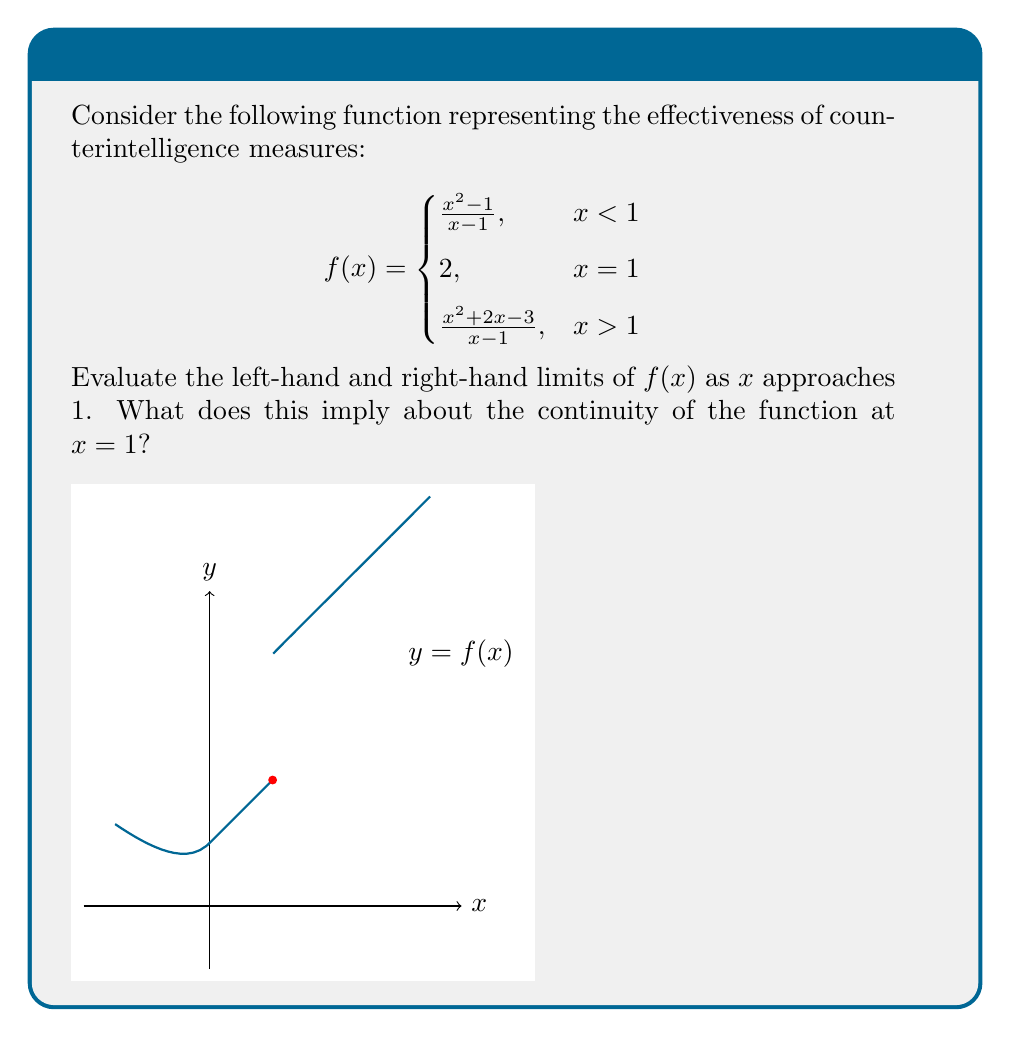Show me your answer to this math problem. Let's approach this step-by-step:

1) For the left-hand limit, we use the first piece of the function:
   $$\lim_{x \to 1^-} f(x) = \lim_{x \to 1^-} \frac{x^2 - 1}{x - 1}$$

   We can factor the numerator:
   $$\lim_{x \to 1^-} \frac{(x+1)(x-1)}{x - 1}$$

   The $(x-1)$ terms cancel out:
   $$\lim_{x \to 1^-} (x+1) = 2$$

2) For the right-hand limit, we use the third piece of the function:
   $$\lim_{x \to 1^+} f(x) = \lim_{x \to 1^+} \frac{x^2 + 2x - 3}{x - 1}$$

   We can factor the numerator:
   $$\lim_{x \to 1^+} \frac{(x+3)(x-1)}{x - 1}$$

   The $(x-1)$ terms cancel out:
   $$\lim_{x \to 1^+} (x+3) = 4$$

3) We see that the left-hand limit (2) and the right-hand limit (4) are different. This means the function is not continuous at $x = 1$.

4) Moreover, neither limit matches the function value at $x = 1$, which is 2.

From a counterintelligence perspective, this discontinuity could represent a sudden change in effectiveness when crossing a certain threshold, perhaps indicating a critical point where defensive measures significantly improve or decline.
Answer: $\lim_{x \to 1^-} f(x) = 2$, $\lim_{x \to 1^+} f(x) = 4$. The function is discontinuous at $x = 1$. 